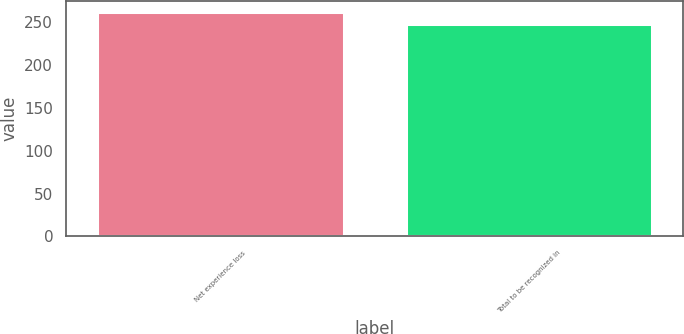Convert chart to OTSL. <chart><loc_0><loc_0><loc_500><loc_500><bar_chart><fcel>Net experience loss<fcel>Total to be recognized in<nl><fcel>261<fcel>247<nl></chart> 